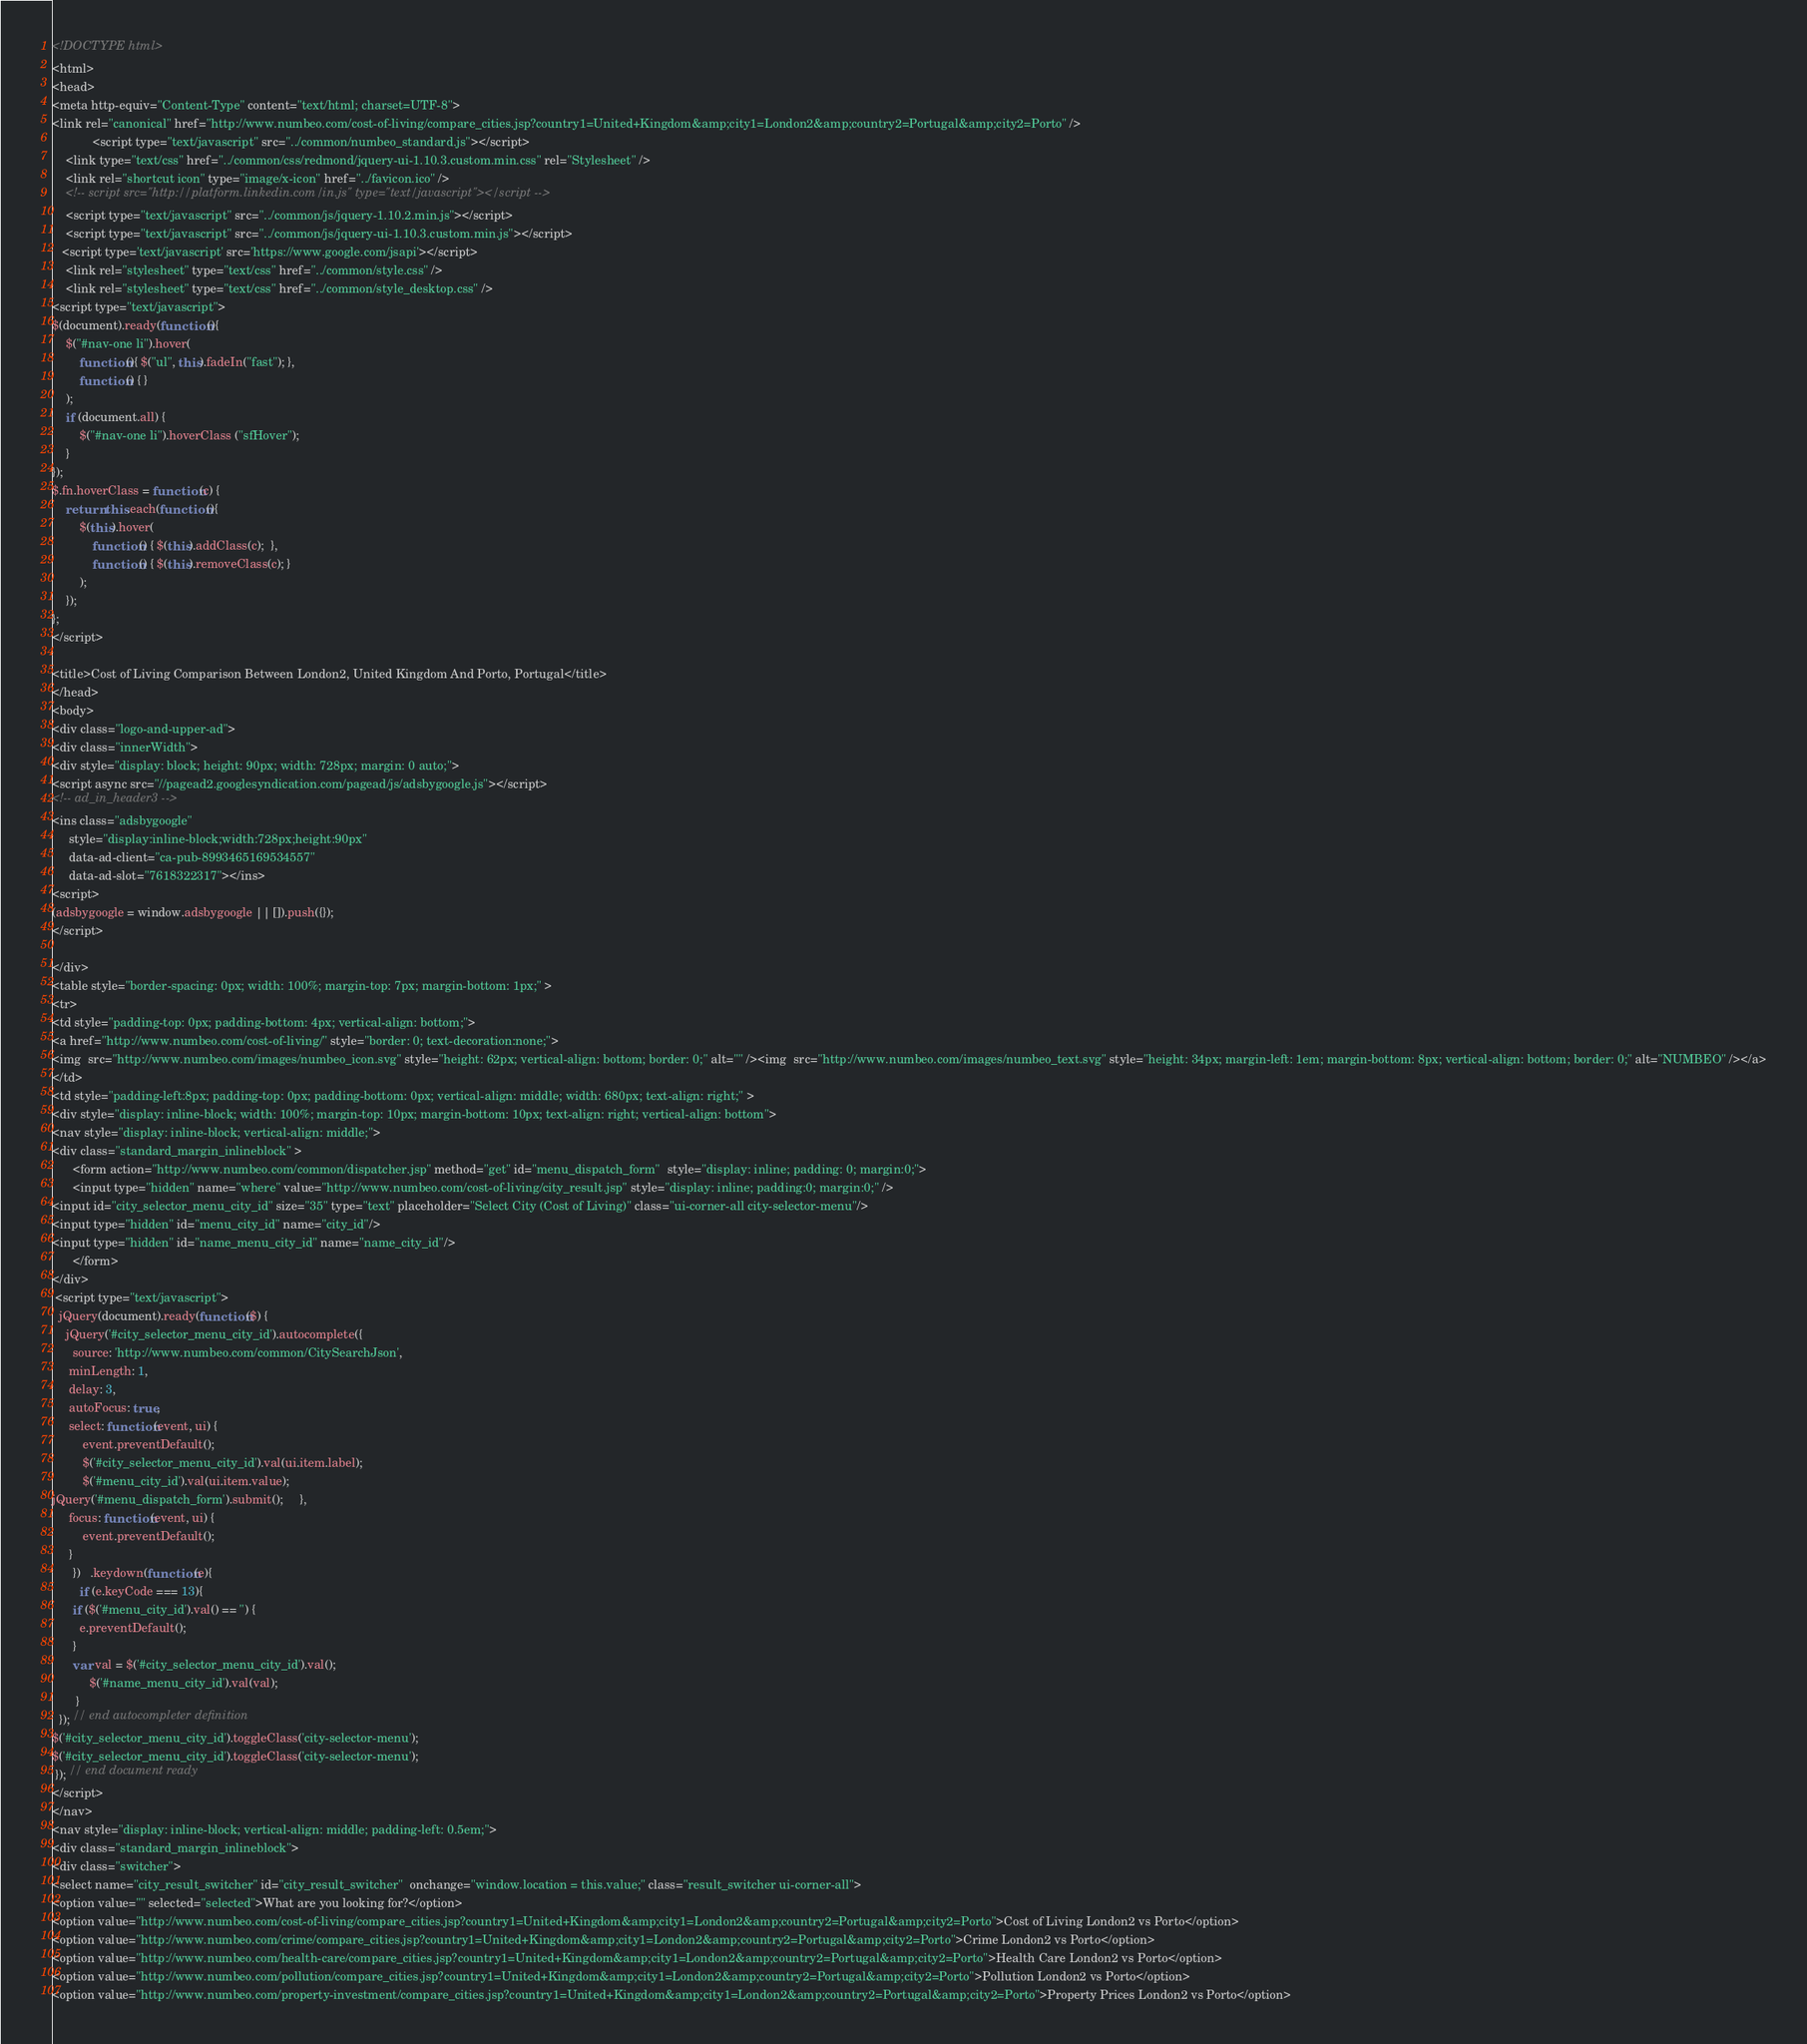Convert code to text. <code><loc_0><loc_0><loc_500><loc_500><_HTML_>
<!DOCTYPE html>
<html>
<head>
<meta http-equiv="Content-Type" content="text/html; charset=UTF-8">
<link rel="canonical" href="http://www.numbeo.com/cost-of-living/compare_cities.jsp?country1=United+Kingdom&amp;city1=London2&amp;country2=Portugal&amp;city2=Porto" />
            <script type="text/javascript" src="../common/numbeo_standard.js"></script>
    <link type="text/css" href="../common/css/redmond/jquery-ui-1.10.3.custom.min.css" rel="Stylesheet" />
    <link rel="shortcut icon" type="image/x-icon" href="../favicon.ico" />
    <!-- script src="http://platform.linkedin.com/in.js" type="text/javascript"></script -->
    <script type="text/javascript" src="../common/js/jquery-1.10.2.min.js"></script>
    <script type="text/javascript" src="../common/js/jquery-ui-1.10.3.custom.min.js"></script>
   <script type='text/javascript' src='https://www.google.com/jsapi'></script>
    <link rel="stylesheet" type="text/css" href="../common/style.css" />
    <link rel="stylesheet" type="text/css" href="../common/style_desktop.css" />
<script type="text/javascript">
$(document).ready(function(){
	$("#nav-one li").hover(
		function(){ $("ul", this).fadeIn("fast"); },
		function() { }
	);
	if (document.all) {
		$("#nav-one li").hoverClass ("sfHover");
	}
});
$.fn.hoverClass = function(c) {
	return this.each(function(){
		$(this).hover(
			function() { $(this).addClass(c);  },
			function() { $(this).removeClass(c); }
		);
	});
};
</script>

<title>Cost of Living Comparison Between London2, United Kingdom And Porto, Portugal</title>
</head>
<body>
<div class="logo-and-upper-ad">
<div class="innerWidth">
<div style="display: block; height: 90px; width: 728px; margin: 0 auto;">
<script async src="//pagead2.googlesyndication.com/pagead/js/adsbygoogle.js"></script>
<!-- ad_in_header3 -->
<ins class="adsbygoogle"
     style="display:inline-block;width:728px;height:90px"
     data-ad-client="ca-pub-8993465169534557"
     data-ad-slot="7618322317"></ins>
<script>
(adsbygoogle = window.adsbygoogle || []).push({});
</script>

</div>
<table style="border-spacing: 0px; width: 100%; margin-top: 7px; margin-bottom: 1px;" >
<tr>
<td style="padding-top: 0px; padding-bottom: 4px; vertical-align: bottom;">
<a href="http://www.numbeo.com/cost-of-living/" style="border: 0; text-decoration:none;">
<img  src="http://www.numbeo.com/images/numbeo_icon.svg" style="height: 62px; vertical-align: bottom; border: 0;" alt="" /><img  src="http://www.numbeo.com/images/numbeo_text.svg" style="height: 34px; margin-left: 1em; margin-bottom: 8px; vertical-align: bottom; border: 0;" alt="NUMBEO" /></a>
</td>
<td style="padding-left:8px; padding-top: 0px; padding-bottom: 0px; vertical-align: middle; width: 680px; text-align: right;" >
<div style="display: inline-block; width: 100%; margin-top: 10px; margin-bottom: 10px; text-align: right; vertical-align: bottom">
<nav style="display: inline-block; vertical-align: middle;">
<div class="standard_margin_inlineblock" >
      <form action="http://www.numbeo.com/common/dispatcher.jsp" method="get" id="menu_dispatch_form"  style="display: inline; padding: 0; margin:0;">
      <input type="hidden" name="where" value="http://www.numbeo.com/cost-of-living/city_result.jsp" style="display: inline; padding:0; margin:0;" />
<input id="city_selector_menu_city_id" size="35" type="text" placeholder="Select City (Cost of Living)" class="ui-corner-all city-selector-menu"/>
<input type="hidden" id="menu_city_id" name="city_id"/>
<input type="hidden" id="name_menu_city_id" name="name_city_id"/>
      </form>
</div>
 <script type="text/javascript">
  jQuery(document).ready(function($) {
  	jQuery('#city_selector_menu_city_id').autocomplete({
  	  source: 'http://www.numbeo.com/common/CitySearchJson',
     minLength: 1,
     delay: 3,
     autoFocus: true,
     select: function(event, ui) {
         event.preventDefault();
         $('#city_selector_menu_city_id').val(ui.item.label);
         $('#menu_city_id').val(ui.item.value);
jQuery('#menu_dispatch_form').submit();     },
     focus: function(event, ui) {
         event.preventDefault();
     }
	  })   .keydown(function(e){
	    if (e.keyCode === 13){
      if ($('#menu_city_id').val() == '') {
        e.preventDefault();
      }
      var val = $('#city_selector_menu_city_id').val();
		   $('#name_menu_city_id').val(val);
	   }
  }); // end autocompleter definition
$('#city_selector_menu_city_id').toggleClass('city-selector-menu');
$('#city_selector_menu_city_id').toggleClass('city-selector-menu');
 }); // end document ready
</script>
</nav>
<nav style="display: inline-block; vertical-align: middle; padding-left: 0.5em;">
<div class="standard_margin_inlineblock">
<div class="switcher">
<select name="city_result_switcher" id="city_result_switcher"  onchange="window.location = this.value;" class="result_switcher ui-corner-all">
<option value="" selected="selected">What are you looking for?</option>
<option value="http://www.numbeo.com/cost-of-living/compare_cities.jsp?country1=United+Kingdom&amp;city1=London2&amp;country2=Portugal&amp;city2=Porto">Cost of Living London2 vs Porto</option>
<option value="http://www.numbeo.com/crime/compare_cities.jsp?country1=United+Kingdom&amp;city1=London2&amp;country2=Portugal&amp;city2=Porto">Crime London2 vs Porto</option>
<option value="http://www.numbeo.com/health-care/compare_cities.jsp?country1=United+Kingdom&amp;city1=London2&amp;country2=Portugal&amp;city2=Porto">Health Care London2 vs Porto</option>
<option value="http://www.numbeo.com/pollution/compare_cities.jsp?country1=United+Kingdom&amp;city1=London2&amp;country2=Portugal&amp;city2=Porto">Pollution London2 vs Porto</option>
<option value="http://www.numbeo.com/property-investment/compare_cities.jsp?country1=United+Kingdom&amp;city1=London2&amp;country2=Portugal&amp;city2=Porto">Property Prices London2 vs Porto</option></code> 